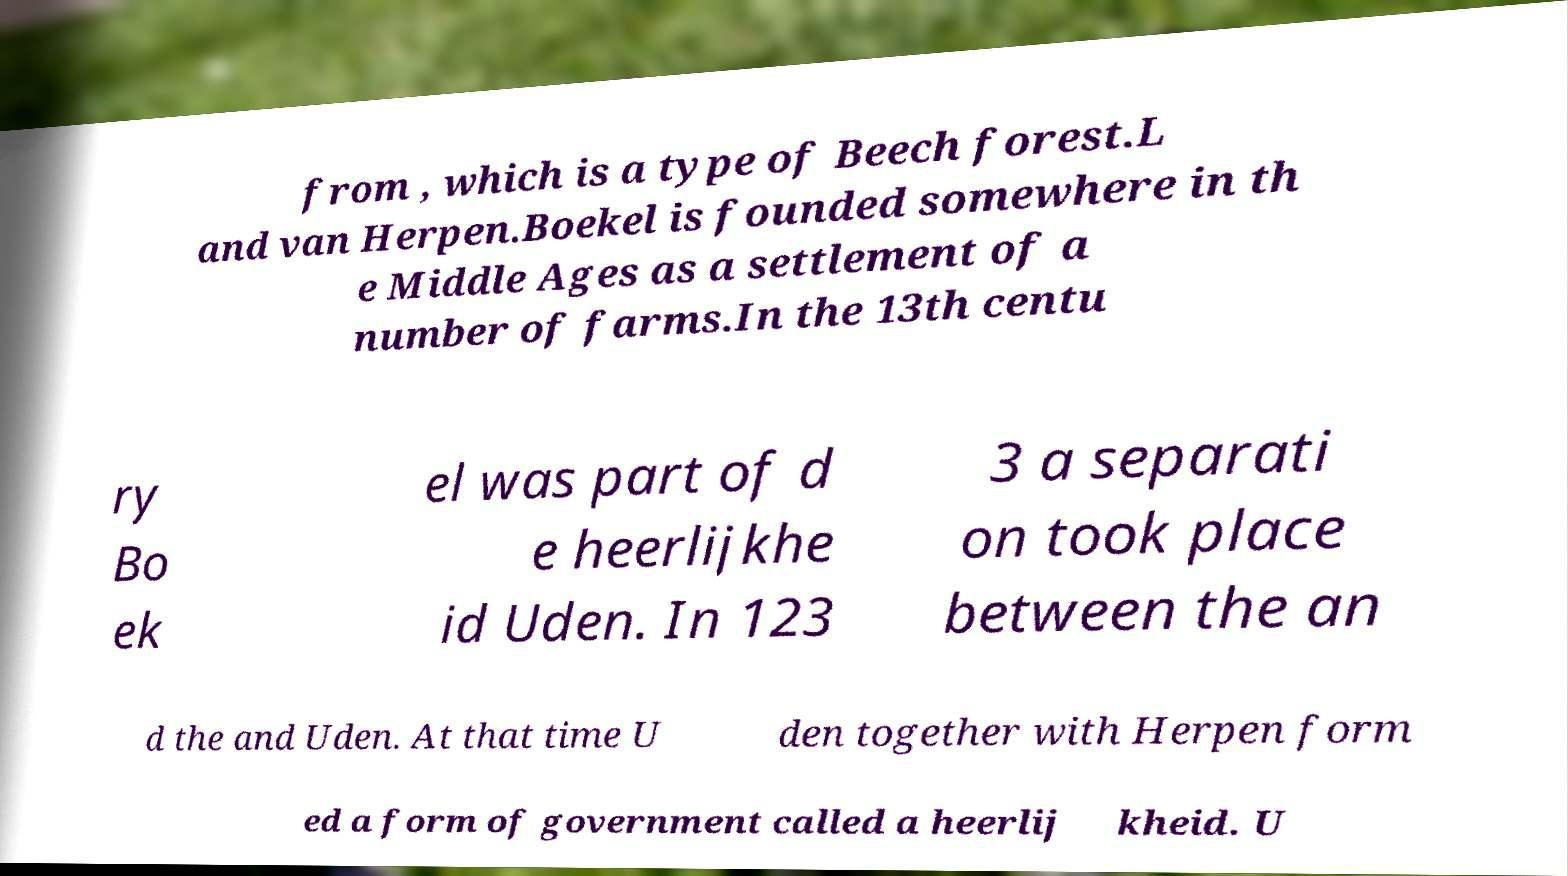Please read and relay the text visible in this image. What does it say? from , which is a type of Beech forest.L and van Herpen.Boekel is founded somewhere in th e Middle Ages as a settlement of a number of farms.In the 13th centu ry Bo ek el was part of d e heerlijkhe id Uden. In 123 3 a separati on took place between the an d the and Uden. At that time U den together with Herpen form ed a form of government called a heerlij kheid. U 